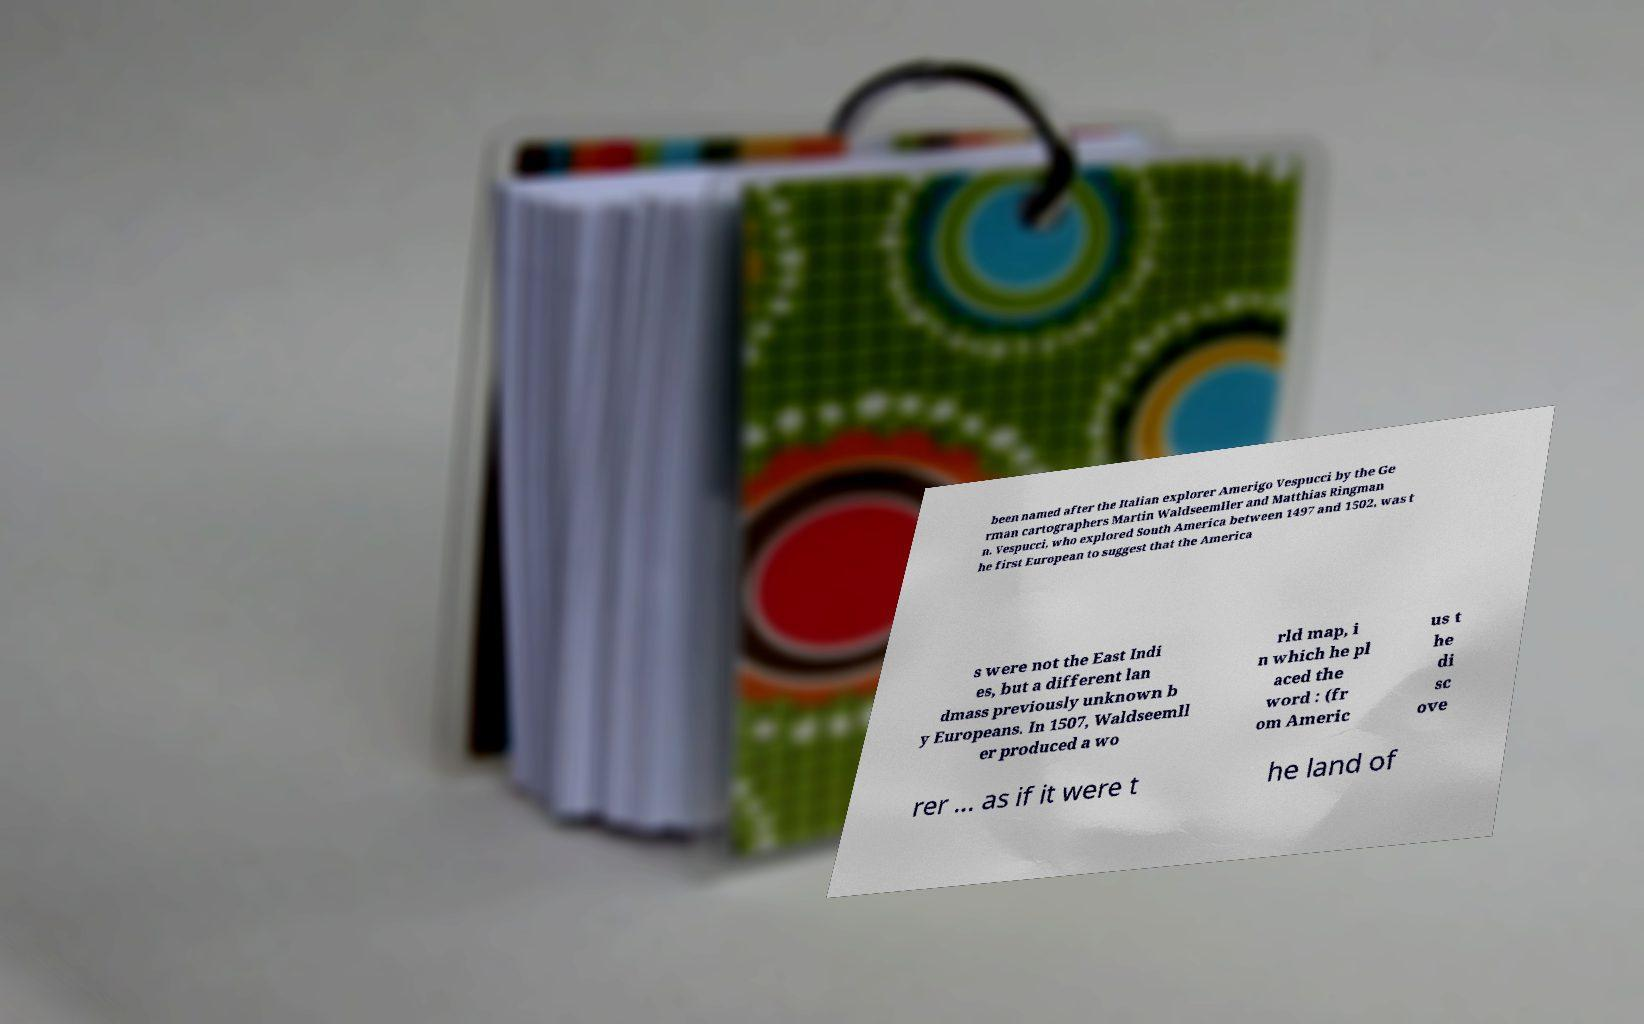Can you accurately transcribe the text from the provided image for me? been named after the Italian explorer Amerigo Vespucci by the Ge rman cartographers Martin Waldseemller and Matthias Ringman n. Vespucci, who explored South America between 1497 and 1502, was t he first European to suggest that the America s were not the East Indi es, but a different lan dmass previously unknown b y Europeans. In 1507, Waldseemll er produced a wo rld map, i n which he pl aced the word : (fr om Americ us t he di sc ove rer ... as if it were t he land of 